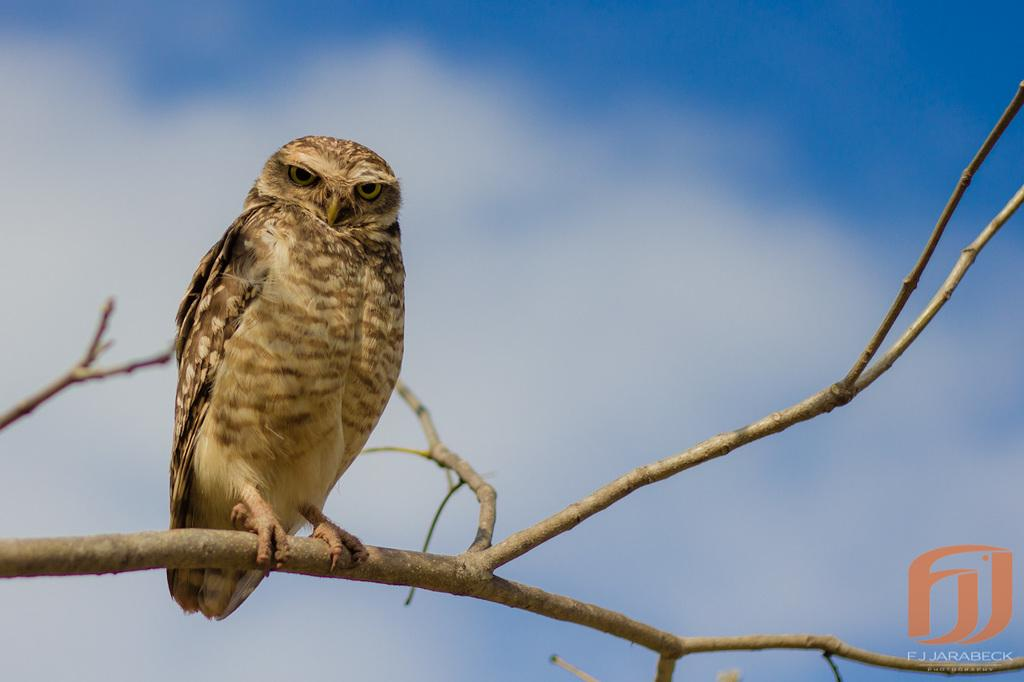What animal is present in the image? There is an owl in the image. Where is the owl located? The owl is on the branch of a tree. What can be seen in the background of the image? The sky is visible in the background of the image. How would you describe the weather based on the sky in the image? The sky appears to be clear, suggesting good weather. How many units of pizzas are being delivered to the owl in the image? There are no pizzas or delivery units present in the image; it features an owl on a tree branch with a clear sky in the background. 